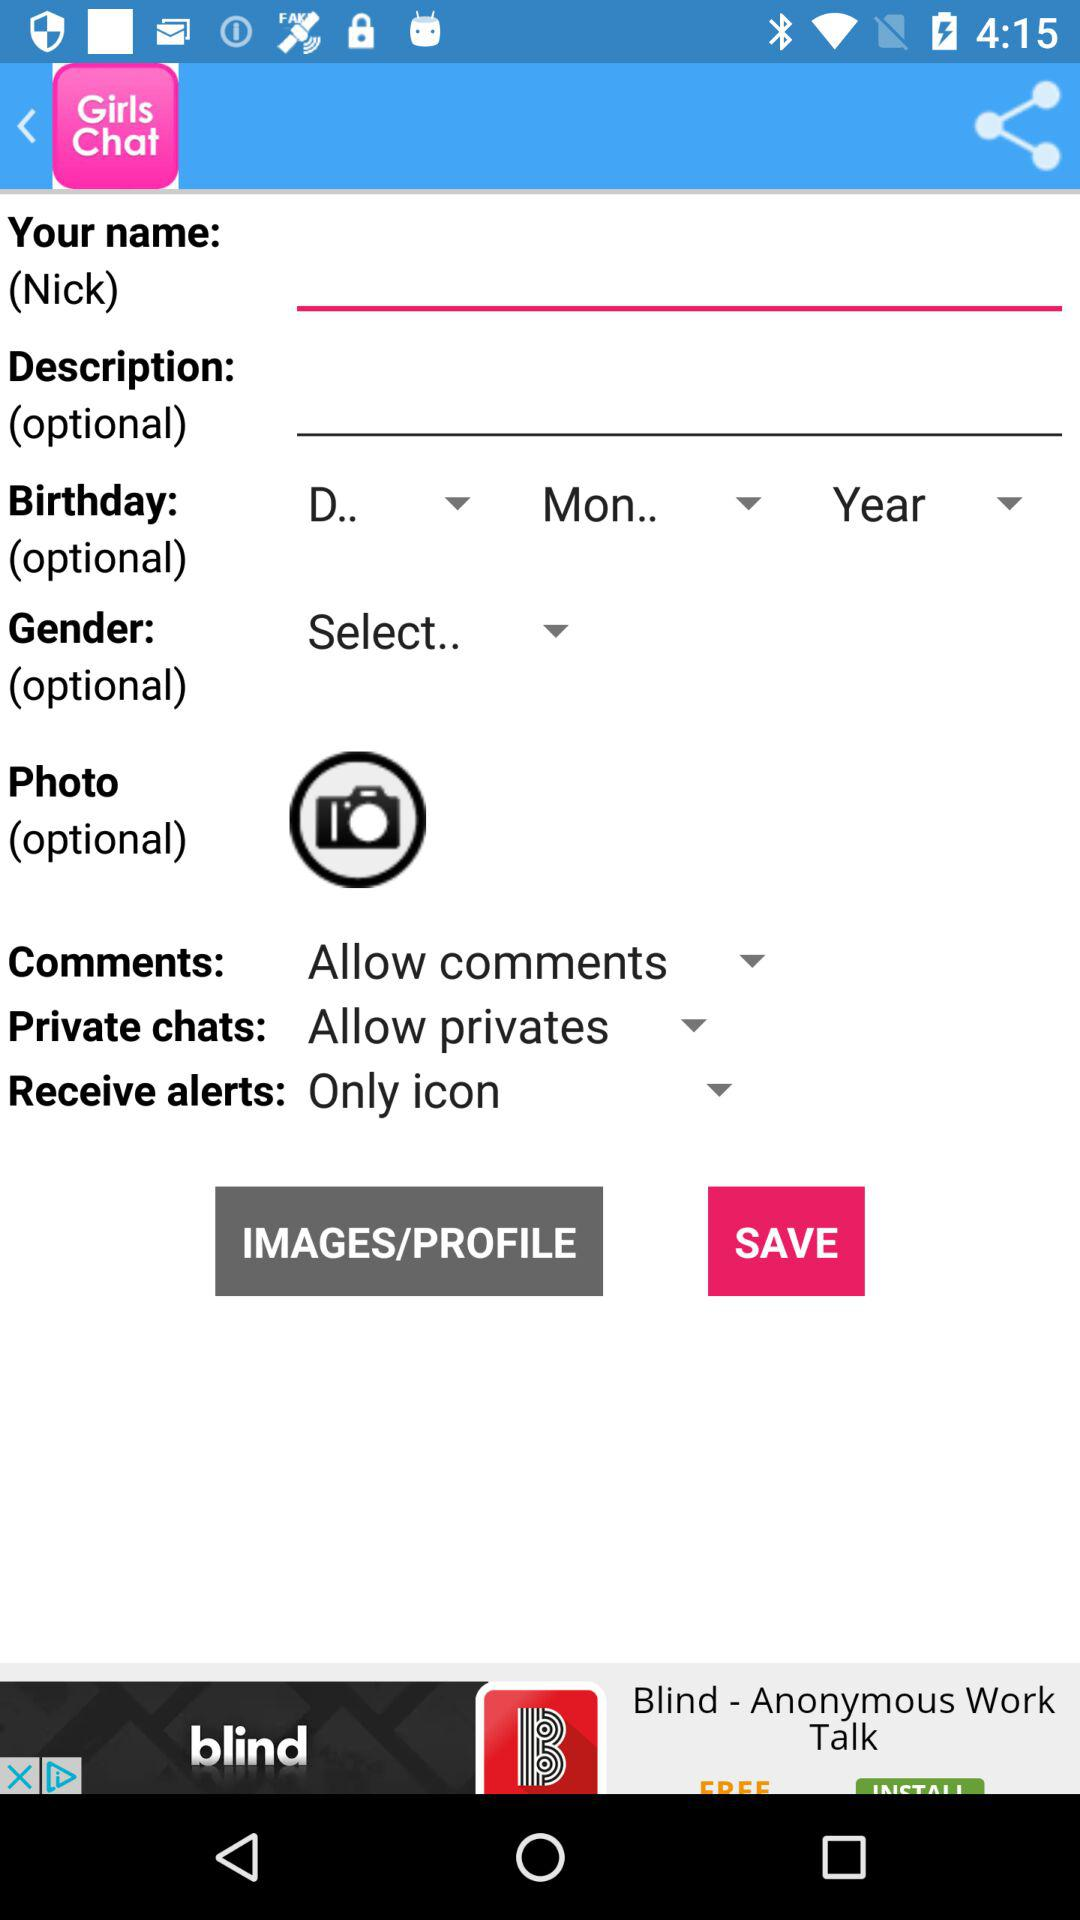What's the setting for "Receive alerts"? The setting for "Receive alerts" is "Only icon". 